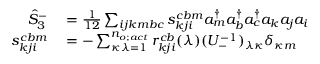Convert formula to latex. <formula><loc_0><loc_0><loc_500><loc_500>\begin{array} { r l } { \hat { S } _ { 3 } ^ { - } } & = \frac { 1 } { 1 2 } \sum _ { i j k m b c } s _ { k j i } ^ { c b m } a _ { m } ^ { \dagger } a _ { b } ^ { \dagger } a _ { c } ^ { \dagger } a _ { k } a _ { j } a _ { i } } \\ { s _ { k j i } ^ { c b m } } & = - \sum _ { \kappa \lambda = 1 } ^ { n _ { o ; a c t } } r _ { k j i } ^ { c b } ( \lambda ) ( U _ { - } ^ { - 1 } ) _ { \lambda \kappa } \delta _ { \kappa m } } \end{array}</formula> 